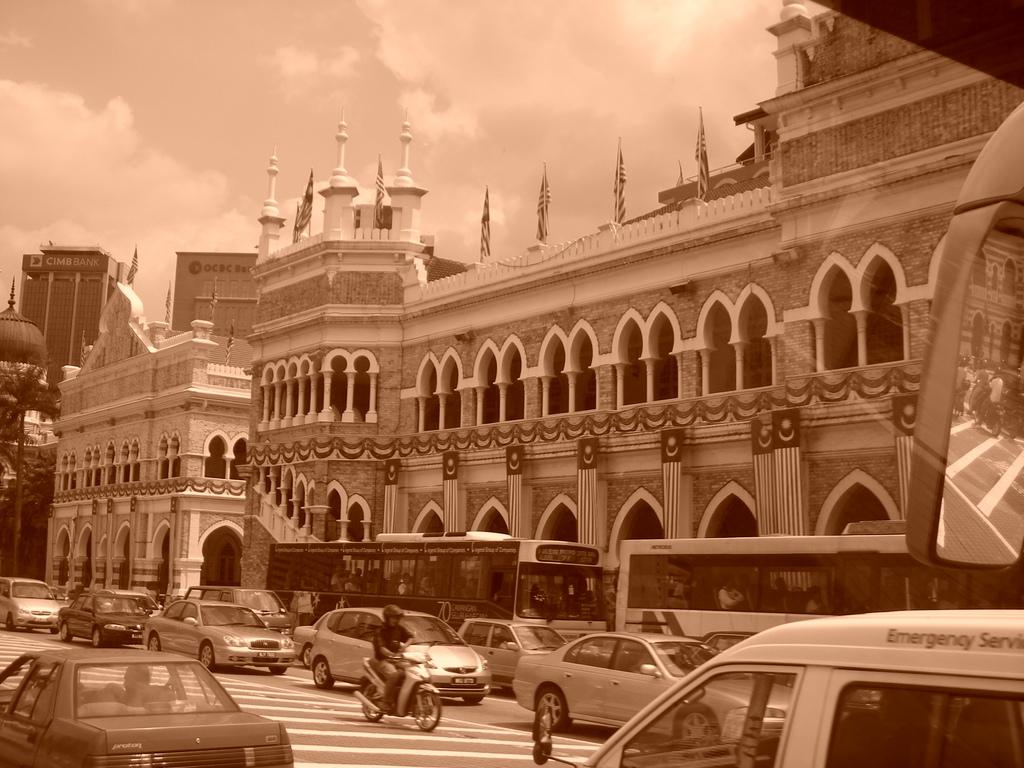What type of structures can be seen in the image? There are buildings in the image. What decorative elements are present on the buildings? There are flags in the image. What architectural features can be observed on the buildings? There are pillars in the image. What type of vegetation is present in the image? There are trees in the image. What type of transportation is visible on the road? There are vehicles on the road in the image. What is visible in the sky? The sky is visible in the image. What game is being played on the roof of the building in the image? There is no game being played on the roof of the building in the image. What wish is granted to the person who finds the hidden object in the image? There is no hidden object or wish-granting activity present in the image. 